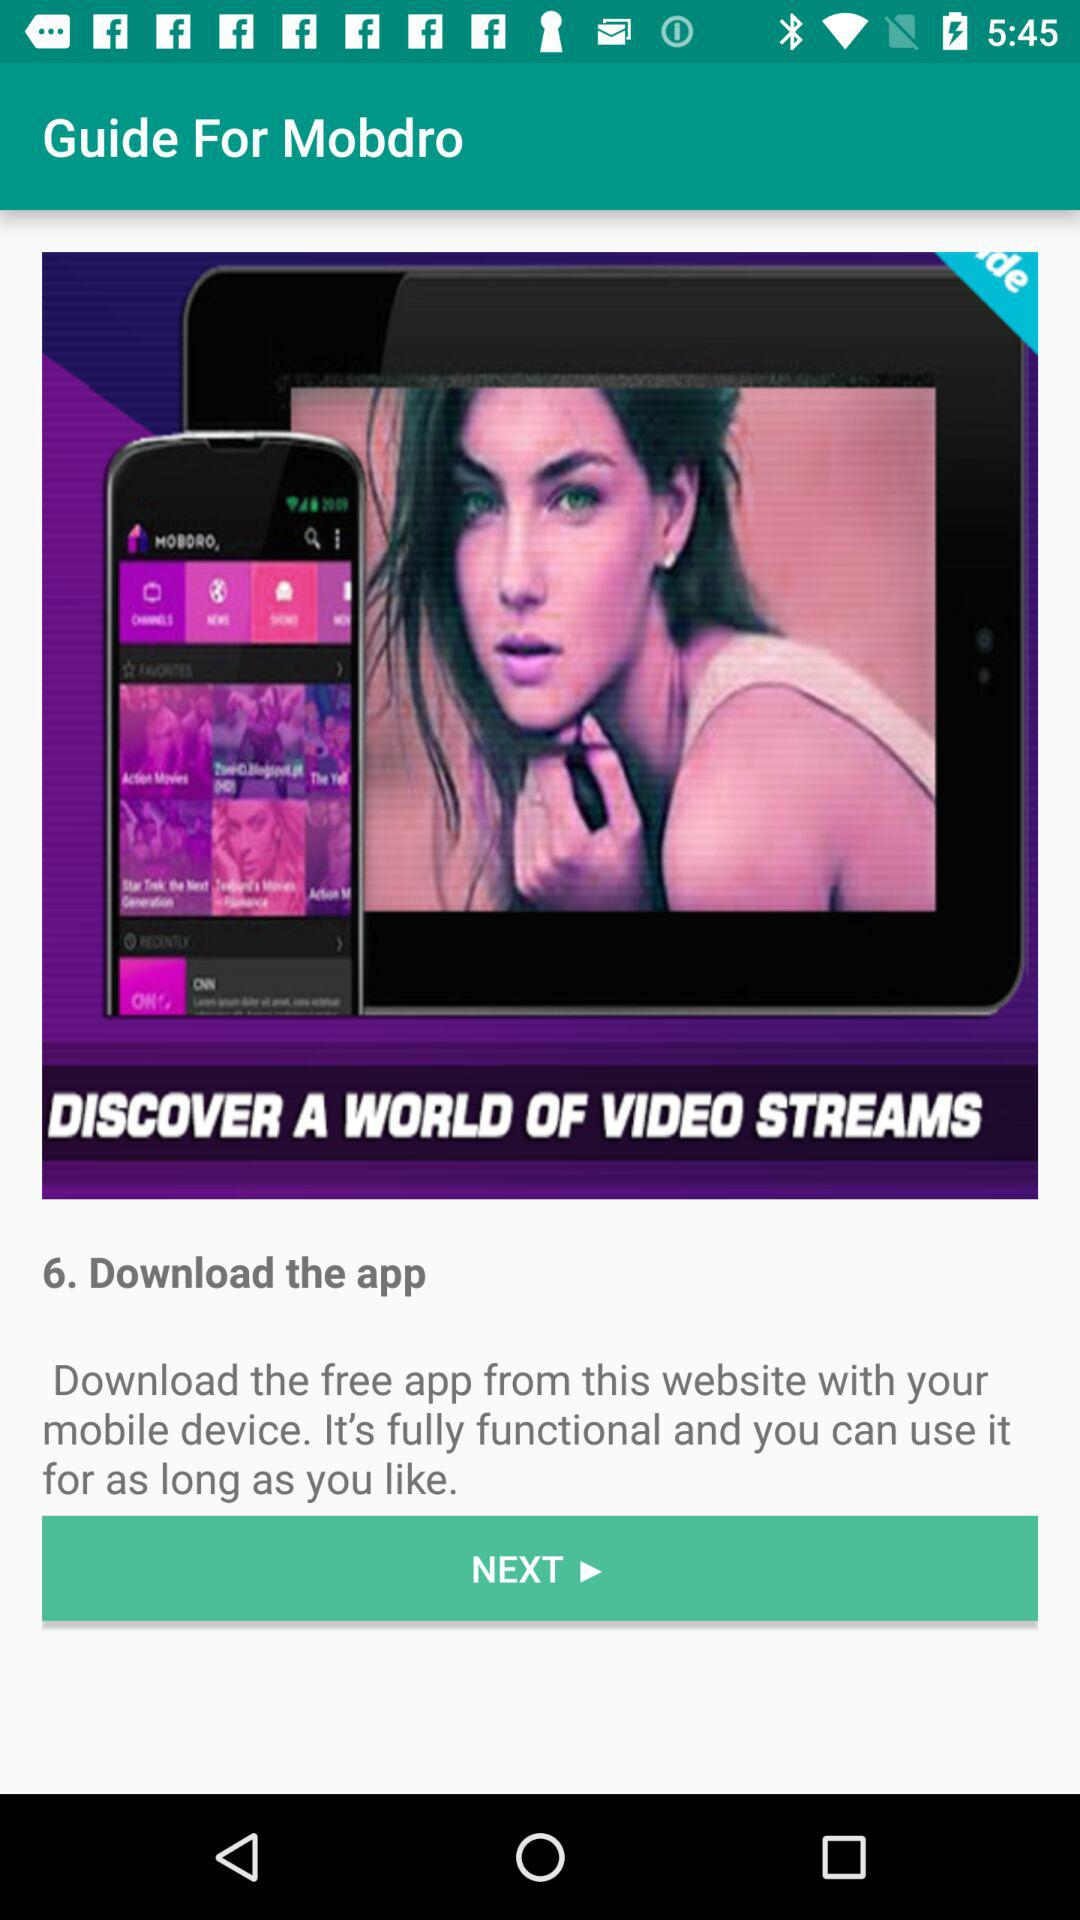How many steps are in the guide?
Answer the question using a single word or phrase. 6 